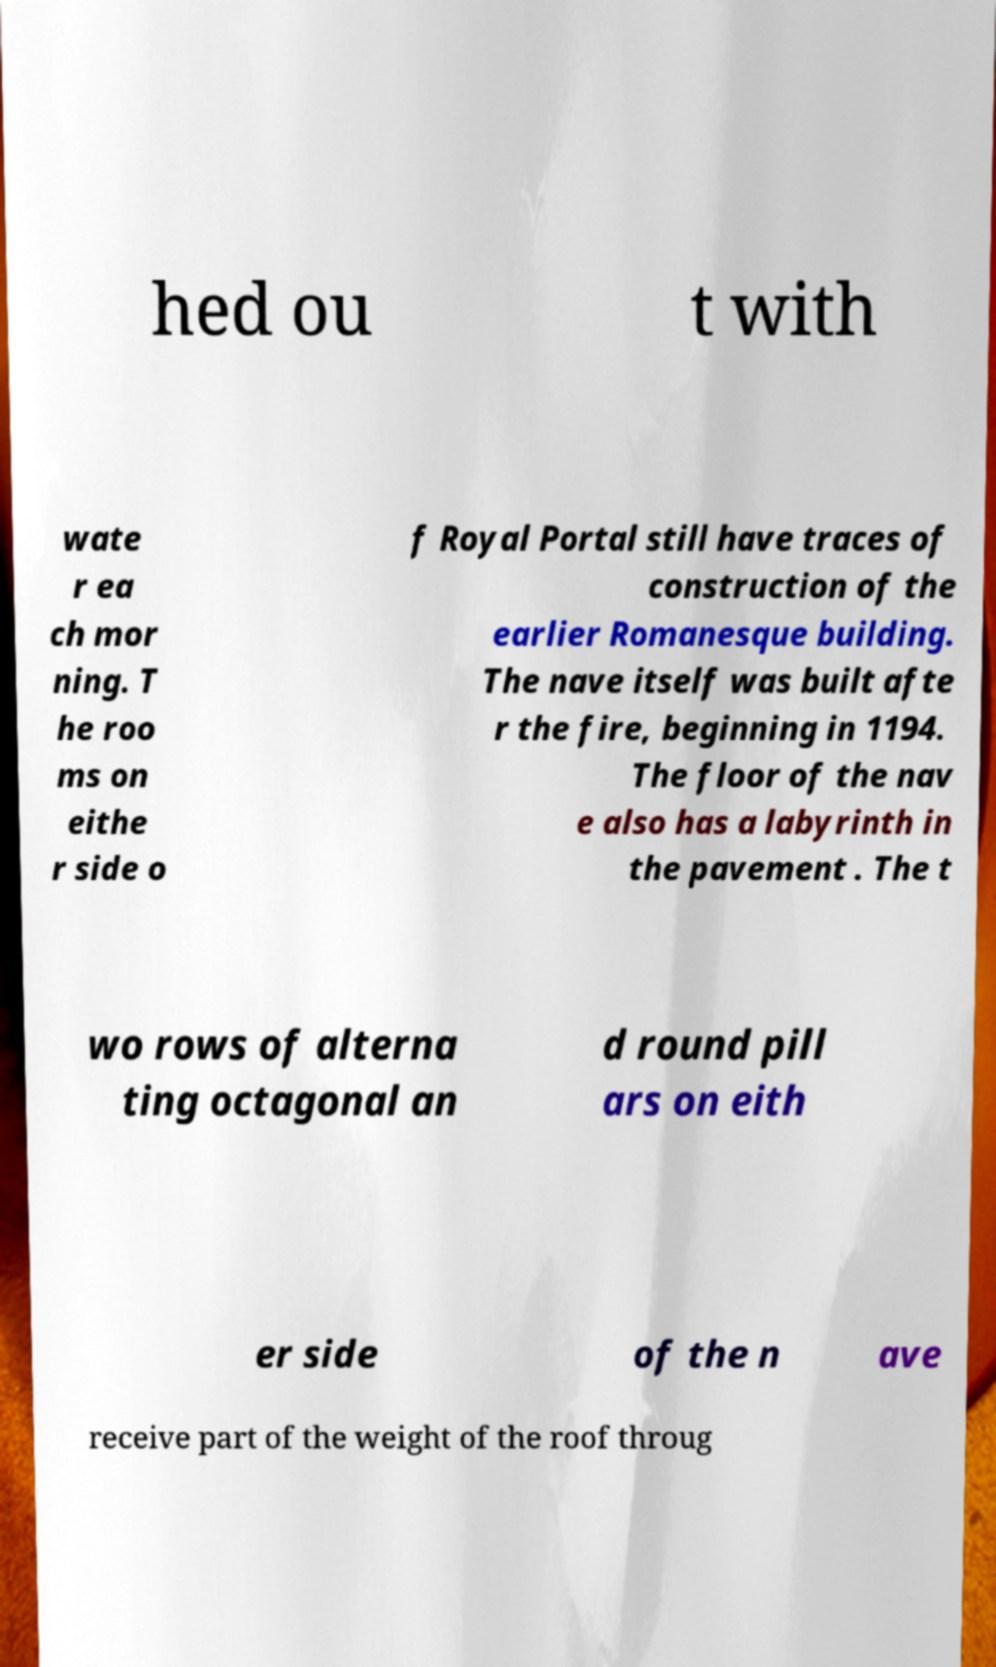Could you assist in decoding the text presented in this image and type it out clearly? hed ou t with wate r ea ch mor ning. T he roo ms on eithe r side o f Royal Portal still have traces of construction of the earlier Romanesque building. The nave itself was built afte r the fire, beginning in 1194. The floor of the nav e also has a labyrinth in the pavement . The t wo rows of alterna ting octagonal an d round pill ars on eith er side of the n ave receive part of the weight of the roof throug 